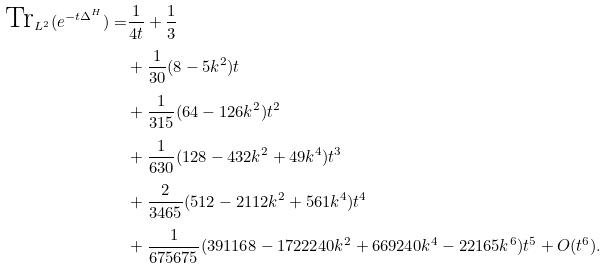<formula> <loc_0><loc_0><loc_500><loc_500>\text {Tr} _ { L ^ { 2 } } ( e ^ { - t \Delta ^ { H } } ) = & \frac { 1 } { 4 t } + \frac { 1 } { 3 } \\ & + \frac { 1 } { 3 0 } ( 8 - 5 k ^ { 2 } ) t \\ & + \frac { 1 } { 3 1 5 } ( 6 4 - 1 2 6 k ^ { 2 } ) t ^ { 2 } \\ & + \frac { 1 } { 6 3 0 } ( 1 2 8 - 4 3 2 k ^ { 2 } + 4 9 k ^ { 4 } ) t ^ { 3 } \\ & + \frac { 2 } { 3 4 6 5 } ( 5 1 2 - 2 1 1 2 k ^ { 2 } + 5 6 1 k ^ { 4 } ) t ^ { 4 } \\ & + \frac { 1 } { 6 7 5 6 7 5 } ( 3 9 1 1 6 8 - 1 7 2 2 2 4 0 k ^ { 2 } + 6 6 9 2 4 0 k ^ { 4 } - 2 2 1 6 5 k ^ { 6 } ) t ^ { 5 } + O ( t ^ { 6 } ) .</formula> 